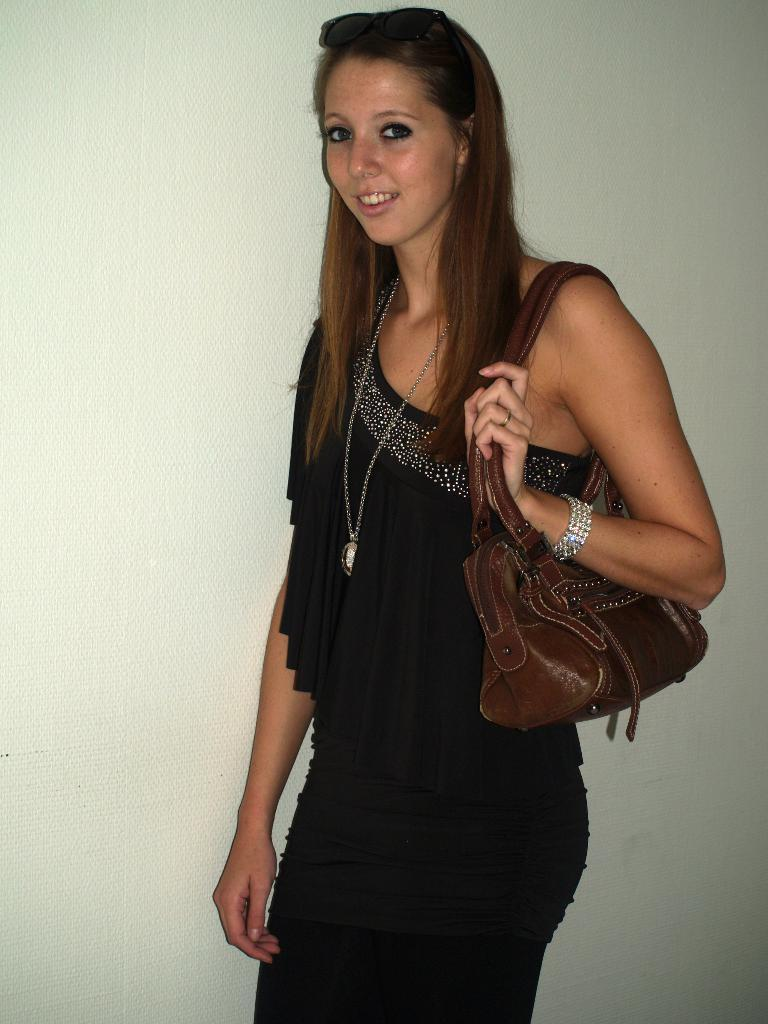Who is present in the image? There is a woman in the image. What is the woman doing in the image? The woman is standing and smiling. What is the woman holding or carrying in the image? The woman is carrying a bag. What can be seen in the background of the image? There is a wall in the background of the image. What type of train can be seen passing by in the image? There is no train present in the image. What are the woman's hobbies, as depicted in the image? The image does not provide information about the woman's hobbies. 